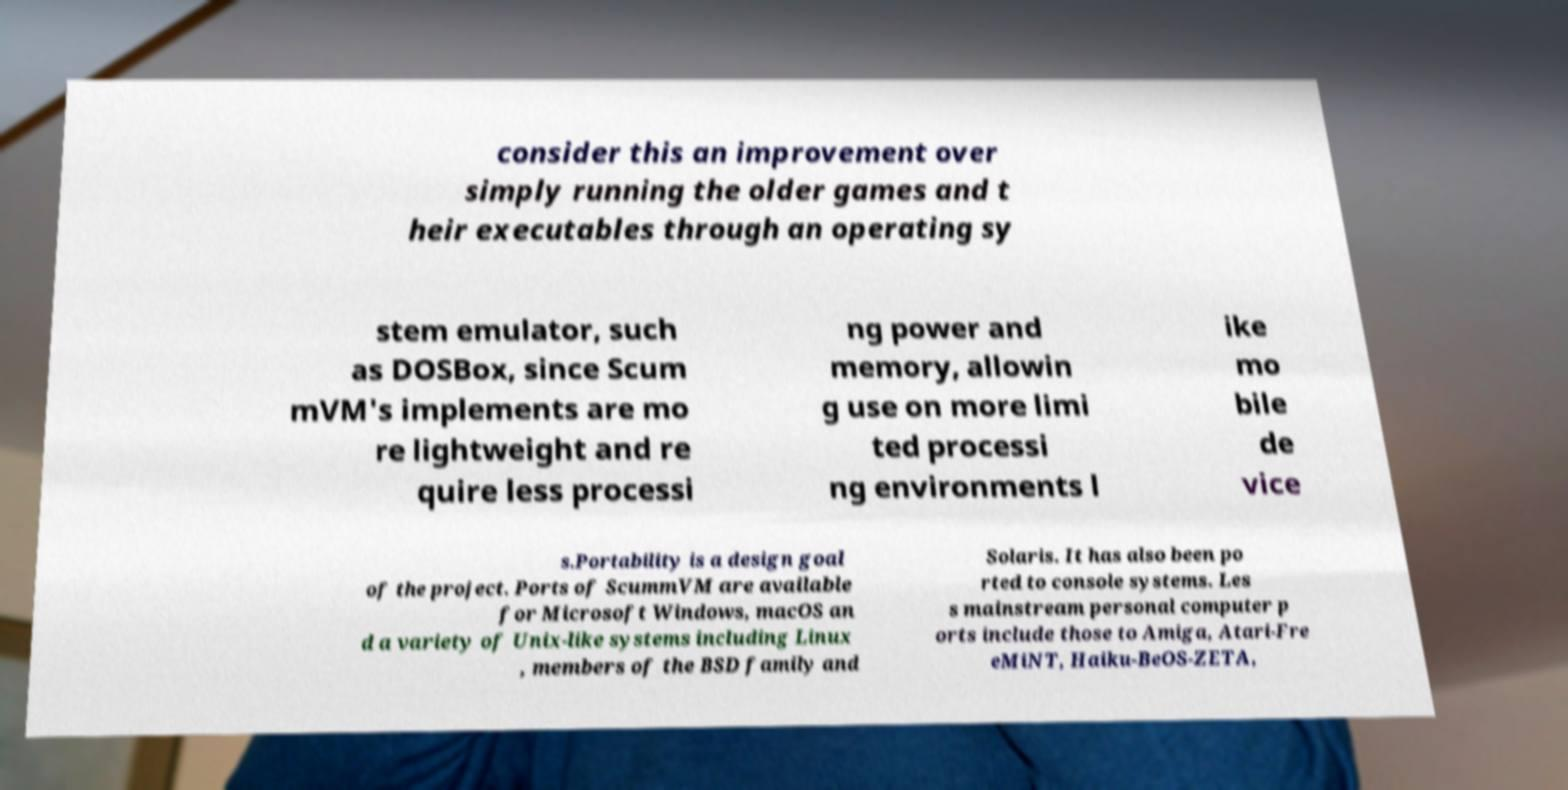Please read and relay the text visible in this image. What does it say? consider this an improvement over simply running the older games and t heir executables through an operating sy stem emulator, such as DOSBox, since Scum mVM's implements are mo re lightweight and re quire less processi ng power and memory, allowin g use on more limi ted processi ng environments l ike mo bile de vice s.Portability is a design goal of the project. Ports of ScummVM are available for Microsoft Windows, macOS an d a variety of Unix-like systems including Linux , members of the BSD family and Solaris. It has also been po rted to console systems. Les s mainstream personal computer p orts include those to Amiga, Atari-Fre eMiNT, Haiku-BeOS-ZETA, 